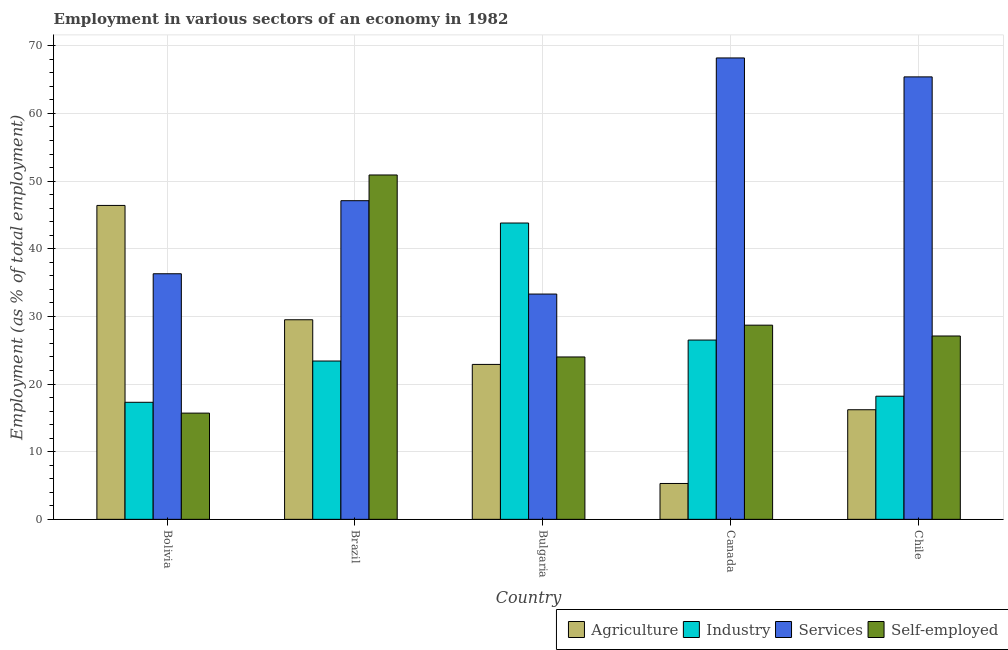How many different coloured bars are there?
Provide a short and direct response. 4. How many groups of bars are there?
Provide a succinct answer. 5. Are the number of bars per tick equal to the number of legend labels?
Provide a succinct answer. Yes. Are the number of bars on each tick of the X-axis equal?
Keep it short and to the point. Yes. How many bars are there on the 1st tick from the left?
Your answer should be compact. 4. How many bars are there on the 2nd tick from the right?
Ensure brevity in your answer.  4. In how many cases, is the number of bars for a given country not equal to the number of legend labels?
Ensure brevity in your answer.  0. What is the percentage of workers in services in Bolivia?
Give a very brief answer. 36.3. Across all countries, what is the maximum percentage of workers in agriculture?
Your answer should be compact. 46.4. Across all countries, what is the minimum percentage of workers in industry?
Give a very brief answer. 17.3. In which country was the percentage of workers in services maximum?
Your answer should be very brief. Canada. What is the total percentage of self employed workers in the graph?
Your answer should be compact. 146.4. What is the difference between the percentage of workers in services in Brazil and that in Chile?
Ensure brevity in your answer.  -18.3. What is the difference between the percentage of workers in agriculture in Canada and the percentage of workers in services in Chile?
Provide a short and direct response. -60.1. What is the average percentage of workers in industry per country?
Ensure brevity in your answer.  25.84. What is the difference between the percentage of self employed workers and percentage of workers in industry in Bolivia?
Ensure brevity in your answer.  -1.6. In how many countries, is the percentage of workers in agriculture greater than 58 %?
Make the answer very short. 0. What is the ratio of the percentage of workers in industry in Bulgaria to that in Canada?
Offer a very short reply. 1.65. Is the percentage of self employed workers in Brazil less than that in Bulgaria?
Your answer should be compact. No. Is the difference between the percentage of workers in agriculture in Canada and Chile greater than the difference between the percentage of self employed workers in Canada and Chile?
Your answer should be very brief. No. What is the difference between the highest and the second highest percentage of workers in services?
Keep it short and to the point. 2.8. What is the difference between the highest and the lowest percentage of workers in agriculture?
Ensure brevity in your answer.  41.1. Is the sum of the percentage of self employed workers in Brazil and Canada greater than the maximum percentage of workers in agriculture across all countries?
Offer a very short reply. Yes. Is it the case that in every country, the sum of the percentage of workers in services and percentage of self employed workers is greater than the sum of percentage of workers in agriculture and percentage of workers in industry?
Keep it short and to the point. No. What does the 4th bar from the left in Chile represents?
Provide a succinct answer. Self-employed. What does the 2nd bar from the right in Canada represents?
Your answer should be very brief. Services. Is it the case that in every country, the sum of the percentage of workers in agriculture and percentage of workers in industry is greater than the percentage of workers in services?
Provide a short and direct response. No. How many bars are there?
Make the answer very short. 20. Are all the bars in the graph horizontal?
Ensure brevity in your answer.  No. What is the difference between two consecutive major ticks on the Y-axis?
Keep it short and to the point. 10. Are the values on the major ticks of Y-axis written in scientific E-notation?
Give a very brief answer. No. Does the graph contain any zero values?
Offer a terse response. No. Does the graph contain grids?
Your answer should be very brief. Yes. Where does the legend appear in the graph?
Ensure brevity in your answer.  Bottom right. How are the legend labels stacked?
Your response must be concise. Horizontal. What is the title of the graph?
Provide a short and direct response. Employment in various sectors of an economy in 1982. What is the label or title of the Y-axis?
Give a very brief answer. Employment (as % of total employment). What is the Employment (as % of total employment) of Agriculture in Bolivia?
Offer a terse response. 46.4. What is the Employment (as % of total employment) in Industry in Bolivia?
Give a very brief answer. 17.3. What is the Employment (as % of total employment) in Services in Bolivia?
Keep it short and to the point. 36.3. What is the Employment (as % of total employment) of Self-employed in Bolivia?
Provide a succinct answer. 15.7. What is the Employment (as % of total employment) in Agriculture in Brazil?
Your answer should be very brief. 29.5. What is the Employment (as % of total employment) in Industry in Brazil?
Ensure brevity in your answer.  23.4. What is the Employment (as % of total employment) of Services in Brazil?
Give a very brief answer. 47.1. What is the Employment (as % of total employment) of Self-employed in Brazil?
Make the answer very short. 50.9. What is the Employment (as % of total employment) of Agriculture in Bulgaria?
Offer a very short reply. 22.9. What is the Employment (as % of total employment) of Industry in Bulgaria?
Give a very brief answer. 43.8. What is the Employment (as % of total employment) in Services in Bulgaria?
Offer a terse response. 33.3. What is the Employment (as % of total employment) of Self-employed in Bulgaria?
Offer a terse response. 24. What is the Employment (as % of total employment) of Agriculture in Canada?
Keep it short and to the point. 5.3. What is the Employment (as % of total employment) of Services in Canada?
Your answer should be compact. 68.2. What is the Employment (as % of total employment) of Self-employed in Canada?
Offer a very short reply. 28.7. What is the Employment (as % of total employment) in Agriculture in Chile?
Offer a very short reply. 16.2. What is the Employment (as % of total employment) of Industry in Chile?
Keep it short and to the point. 18.2. What is the Employment (as % of total employment) in Services in Chile?
Give a very brief answer. 65.4. What is the Employment (as % of total employment) in Self-employed in Chile?
Offer a terse response. 27.1. Across all countries, what is the maximum Employment (as % of total employment) in Agriculture?
Offer a terse response. 46.4. Across all countries, what is the maximum Employment (as % of total employment) of Industry?
Provide a succinct answer. 43.8. Across all countries, what is the maximum Employment (as % of total employment) in Services?
Offer a very short reply. 68.2. Across all countries, what is the maximum Employment (as % of total employment) of Self-employed?
Offer a terse response. 50.9. Across all countries, what is the minimum Employment (as % of total employment) in Agriculture?
Your answer should be compact. 5.3. Across all countries, what is the minimum Employment (as % of total employment) in Industry?
Your response must be concise. 17.3. Across all countries, what is the minimum Employment (as % of total employment) in Services?
Provide a short and direct response. 33.3. Across all countries, what is the minimum Employment (as % of total employment) of Self-employed?
Provide a succinct answer. 15.7. What is the total Employment (as % of total employment) in Agriculture in the graph?
Keep it short and to the point. 120.3. What is the total Employment (as % of total employment) of Industry in the graph?
Provide a short and direct response. 129.2. What is the total Employment (as % of total employment) in Services in the graph?
Make the answer very short. 250.3. What is the total Employment (as % of total employment) in Self-employed in the graph?
Provide a succinct answer. 146.4. What is the difference between the Employment (as % of total employment) in Agriculture in Bolivia and that in Brazil?
Your answer should be compact. 16.9. What is the difference between the Employment (as % of total employment) of Self-employed in Bolivia and that in Brazil?
Make the answer very short. -35.2. What is the difference between the Employment (as % of total employment) of Industry in Bolivia and that in Bulgaria?
Make the answer very short. -26.5. What is the difference between the Employment (as % of total employment) of Agriculture in Bolivia and that in Canada?
Provide a short and direct response. 41.1. What is the difference between the Employment (as % of total employment) in Services in Bolivia and that in Canada?
Provide a short and direct response. -31.9. What is the difference between the Employment (as % of total employment) of Agriculture in Bolivia and that in Chile?
Your answer should be very brief. 30.2. What is the difference between the Employment (as % of total employment) of Services in Bolivia and that in Chile?
Provide a succinct answer. -29.1. What is the difference between the Employment (as % of total employment) in Self-employed in Bolivia and that in Chile?
Your answer should be compact. -11.4. What is the difference between the Employment (as % of total employment) in Industry in Brazil and that in Bulgaria?
Offer a very short reply. -20.4. What is the difference between the Employment (as % of total employment) in Self-employed in Brazil and that in Bulgaria?
Your answer should be very brief. 26.9. What is the difference between the Employment (as % of total employment) in Agriculture in Brazil and that in Canada?
Make the answer very short. 24.2. What is the difference between the Employment (as % of total employment) in Industry in Brazil and that in Canada?
Your response must be concise. -3.1. What is the difference between the Employment (as % of total employment) in Services in Brazil and that in Canada?
Your response must be concise. -21.1. What is the difference between the Employment (as % of total employment) in Agriculture in Brazil and that in Chile?
Make the answer very short. 13.3. What is the difference between the Employment (as % of total employment) of Industry in Brazil and that in Chile?
Give a very brief answer. 5.2. What is the difference between the Employment (as % of total employment) in Services in Brazil and that in Chile?
Keep it short and to the point. -18.3. What is the difference between the Employment (as % of total employment) of Self-employed in Brazil and that in Chile?
Offer a terse response. 23.8. What is the difference between the Employment (as % of total employment) of Services in Bulgaria and that in Canada?
Provide a succinct answer. -34.9. What is the difference between the Employment (as % of total employment) of Agriculture in Bulgaria and that in Chile?
Offer a very short reply. 6.7. What is the difference between the Employment (as % of total employment) of Industry in Bulgaria and that in Chile?
Your answer should be compact. 25.6. What is the difference between the Employment (as % of total employment) in Services in Bulgaria and that in Chile?
Provide a succinct answer. -32.1. What is the difference between the Employment (as % of total employment) of Self-employed in Canada and that in Chile?
Offer a very short reply. 1.6. What is the difference between the Employment (as % of total employment) in Agriculture in Bolivia and the Employment (as % of total employment) in Industry in Brazil?
Give a very brief answer. 23. What is the difference between the Employment (as % of total employment) of Agriculture in Bolivia and the Employment (as % of total employment) of Services in Brazil?
Offer a terse response. -0.7. What is the difference between the Employment (as % of total employment) of Industry in Bolivia and the Employment (as % of total employment) of Services in Brazil?
Offer a very short reply. -29.8. What is the difference between the Employment (as % of total employment) of Industry in Bolivia and the Employment (as % of total employment) of Self-employed in Brazil?
Offer a very short reply. -33.6. What is the difference between the Employment (as % of total employment) of Services in Bolivia and the Employment (as % of total employment) of Self-employed in Brazil?
Provide a succinct answer. -14.6. What is the difference between the Employment (as % of total employment) in Agriculture in Bolivia and the Employment (as % of total employment) in Industry in Bulgaria?
Make the answer very short. 2.6. What is the difference between the Employment (as % of total employment) in Agriculture in Bolivia and the Employment (as % of total employment) in Services in Bulgaria?
Provide a succinct answer. 13.1. What is the difference between the Employment (as % of total employment) in Agriculture in Bolivia and the Employment (as % of total employment) in Self-employed in Bulgaria?
Offer a terse response. 22.4. What is the difference between the Employment (as % of total employment) of Industry in Bolivia and the Employment (as % of total employment) of Services in Bulgaria?
Your answer should be compact. -16. What is the difference between the Employment (as % of total employment) in Industry in Bolivia and the Employment (as % of total employment) in Self-employed in Bulgaria?
Offer a terse response. -6.7. What is the difference between the Employment (as % of total employment) in Services in Bolivia and the Employment (as % of total employment) in Self-employed in Bulgaria?
Give a very brief answer. 12.3. What is the difference between the Employment (as % of total employment) in Agriculture in Bolivia and the Employment (as % of total employment) in Services in Canada?
Give a very brief answer. -21.8. What is the difference between the Employment (as % of total employment) of Agriculture in Bolivia and the Employment (as % of total employment) of Self-employed in Canada?
Offer a very short reply. 17.7. What is the difference between the Employment (as % of total employment) of Industry in Bolivia and the Employment (as % of total employment) of Services in Canada?
Your answer should be very brief. -50.9. What is the difference between the Employment (as % of total employment) of Services in Bolivia and the Employment (as % of total employment) of Self-employed in Canada?
Ensure brevity in your answer.  7.6. What is the difference between the Employment (as % of total employment) in Agriculture in Bolivia and the Employment (as % of total employment) in Industry in Chile?
Make the answer very short. 28.2. What is the difference between the Employment (as % of total employment) in Agriculture in Bolivia and the Employment (as % of total employment) in Self-employed in Chile?
Offer a terse response. 19.3. What is the difference between the Employment (as % of total employment) of Industry in Bolivia and the Employment (as % of total employment) of Services in Chile?
Provide a succinct answer. -48.1. What is the difference between the Employment (as % of total employment) in Industry in Bolivia and the Employment (as % of total employment) in Self-employed in Chile?
Give a very brief answer. -9.8. What is the difference between the Employment (as % of total employment) in Agriculture in Brazil and the Employment (as % of total employment) in Industry in Bulgaria?
Offer a terse response. -14.3. What is the difference between the Employment (as % of total employment) of Agriculture in Brazil and the Employment (as % of total employment) of Self-employed in Bulgaria?
Your answer should be very brief. 5.5. What is the difference between the Employment (as % of total employment) of Industry in Brazil and the Employment (as % of total employment) of Services in Bulgaria?
Offer a very short reply. -9.9. What is the difference between the Employment (as % of total employment) in Services in Brazil and the Employment (as % of total employment) in Self-employed in Bulgaria?
Make the answer very short. 23.1. What is the difference between the Employment (as % of total employment) of Agriculture in Brazil and the Employment (as % of total employment) of Services in Canada?
Provide a succinct answer. -38.7. What is the difference between the Employment (as % of total employment) of Industry in Brazil and the Employment (as % of total employment) of Services in Canada?
Provide a short and direct response. -44.8. What is the difference between the Employment (as % of total employment) in Services in Brazil and the Employment (as % of total employment) in Self-employed in Canada?
Your answer should be very brief. 18.4. What is the difference between the Employment (as % of total employment) of Agriculture in Brazil and the Employment (as % of total employment) of Services in Chile?
Your response must be concise. -35.9. What is the difference between the Employment (as % of total employment) of Agriculture in Brazil and the Employment (as % of total employment) of Self-employed in Chile?
Offer a terse response. 2.4. What is the difference between the Employment (as % of total employment) of Industry in Brazil and the Employment (as % of total employment) of Services in Chile?
Your answer should be compact. -42. What is the difference between the Employment (as % of total employment) of Industry in Brazil and the Employment (as % of total employment) of Self-employed in Chile?
Keep it short and to the point. -3.7. What is the difference between the Employment (as % of total employment) in Services in Brazil and the Employment (as % of total employment) in Self-employed in Chile?
Your answer should be compact. 20. What is the difference between the Employment (as % of total employment) in Agriculture in Bulgaria and the Employment (as % of total employment) in Industry in Canada?
Ensure brevity in your answer.  -3.6. What is the difference between the Employment (as % of total employment) of Agriculture in Bulgaria and the Employment (as % of total employment) of Services in Canada?
Give a very brief answer. -45.3. What is the difference between the Employment (as % of total employment) in Industry in Bulgaria and the Employment (as % of total employment) in Services in Canada?
Provide a short and direct response. -24.4. What is the difference between the Employment (as % of total employment) in Services in Bulgaria and the Employment (as % of total employment) in Self-employed in Canada?
Your answer should be very brief. 4.6. What is the difference between the Employment (as % of total employment) of Agriculture in Bulgaria and the Employment (as % of total employment) of Industry in Chile?
Give a very brief answer. 4.7. What is the difference between the Employment (as % of total employment) in Agriculture in Bulgaria and the Employment (as % of total employment) in Services in Chile?
Give a very brief answer. -42.5. What is the difference between the Employment (as % of total employment) of Industry in Bulgaria and the Employment (as % of total employment) of Services in Chile?
Your answer should be compact. -21.6. What is the difference between the Employment (as % of total employment) of Agriculture in Canada and the Employment (as % of total employment) of Industry in Chile?
Keep it short and to the point. -12.9. What is the difference between the Employment (as % of total employment) of Agriculture in Canada and the Employment (as % of total employment) of Services in Chile?
Provide a succinct answer. -60.1. What is the difference between the Employment (as % of total employment) in Agriculture in Canada and the Employment (as % of total employment) in Self-employed in Chile?
Give a very brief answer. -21.8. What is the difference between the Employment (as % of total employment) in Industry in Canada and the Employment (as % of total employment) in Services in Chile?
Keep it short and to the point. -38.9. What is the difference between the Employment (as % of total employment) of Services in Canada and the Employment (as % of total employment) of Self-employed in Chile?
Offer a terse response. 41.1. What is the average Employment (as % of total employment) of Agriculture per country?
Keep it short and to the point. 24.06. What is the average Employment (as % of total employment) in Industry per country?
Ensure brevity in your answer.  25.84. What is the average Employment (as % of total employment) of Services per country?
Offer a terse response. 50.06. What is the average Employment (as % of total employment) of Self-employed per country?
Your answer should be compact. 29.28. What is the difference between the Employment (as % of total employment) of Agriculture and Employment (as % of total employment) of Industry in Bolivia?
Ensure brevity in your answer.  29.1. What is the difference between the Employment (as % of total employment) in Agriculture and Employment (as % of total employment) in Services in Bolivia?
Give a very brief answer. 10.1. What is the difference between the Employment (as % of total employment) of Agriculture and Employment (as % of total employment) of Self-employed in Bolivia?
Your answer should be compact. 30.7. What is the difference between the Employment (as % of total employment) of Industry and Employment (as % of total employment) of Services in Bolivia?
Offer a terse response. -19. What is the difference between the Employment (as % of total employment) in Services and Employment (as % of total employment) in Self-employed in Bolivia?
Provide a short and direct response. 20.6. What is the difference between the Employment (as % of total employment) of Agriculture and Employment (as % of total employment) of Services in Brazil?
Keep it short and to the point. -17.6. What is the difference between the Employment (as % of total employment) in Agriculture and Employment (as % of total employment) in Self-employed in Brazil?
Give a very brief answer. -21.4. What is the difference between the Employment (as % of total employment) of Industry and Employment (as % of total employment) of Services in Brazil?
Offer a very short reply. -23.7. What is the difference between the Employment (as % of total employment) in Industry and Employment (as % of total employment) in Self-employed in Brazil?
Offer a very short reply. -27.5. What is the difference between the Employment (as % of total employment) of Agriculture and Employment (as % of total employment) of Industry in Bulgaria?
Keep it short and to the point. -20.9. What is the difference between the Employment (as % of total employment) of Industry and Employment (as % of total employment) of Self-employed in Bulgaria?
Your answer should be compact. 19.8. What is the difference between the Employment (as % of total employment) in Services and Employment (as % of total employment) in Self-employed in Bulgaria?
Ensure brevity in your answer.  9.3. What is the difference between the Employment (as % of total employment) in Agriculture and Employment (as % of total employment) in Industry in Canada?
Provide a succinct answer. -21.2. What is the difference between the Employment (as % of total employment) in Agriculture and Employment (as % of total employment) in Services in Canada?
Offer a very short reply. -62.9. What is the difference between the Employment (as % of total employment) in Agriculture and Employment (as % of total employment) in Self-employed in Canada?
Ensure brevity in your answer.  -23.4. What is the difference between the Employment (as % of total employment) in Industry and Employment (as % of total employment) in Services in Canada?
Your response must be concise. -41.7. What is the difference between the Employment (as % of total employment) of Services and Employment (as % of total employment) of Self-employed in Canada?
Your answer should be very brief. 39.5. What is the difference between the Employment (as % of total employment) in Agriculture and Employment (as % of total employment) in Services in Chile?
Provide a short and direct response. -49.2. What is the difference between the Employment (as % of total employment) in Industry and Employment (as % of total employment) in Services in Chile?
Provide a short and direct response. -47.2. What is the difference between the Employment (as % of total employment) of Industry and Employment (as % of total employment) of Self-employed in Chile?
Provide a succinct answer. -8.9. What is the difference between the Employment (as % of total employment) in Services and Employment (as % of total employment) in Self-employed in Chile?
Your answer should be very brief. 38.3. What is the ratio of the Employment (as % of total employment) in Agriculture in Bolivia to that in Brazil?
Provide a short and direct response. 1.57. What is the ratio of the Employment (as % of total employment) in Industry in Bolivia to that in Brazil?
Your answer should be compact. 0.74. What is the ratio of the Employment (as % of total employment) of Services in Bolivia to that in Brazil?
Provide a succinct answer. 0.77. What is the ratio of the Employment (as % of total employment) in Self-employed in Bolivia to that in Brazil?
Your answer should be compact. 0.31. What is the ratio of the Employment (as % of total employment) of Agriculture in Bolivia to that in Bulgaria?
Your response must be concise. 2.03. What is the ratio of the Employment (as % of total employment) of Industry in Bolivia to that in Bulgaria?
Provide a succinct answer. 0.4. What is the ratio of the Employment (as % of total employment) in Services in Bolivia to that in Bulgaria?
Provide a succinct answer. 1.09. What is the ratio of the Employment (as % of total employment) of Self-employed in Bolivia to that in Bulgaria?
Offer a terse response. 0.65. What is the ratio of the Employment (as % of total employment) in Agriculture in Bolivia to that in Canada?
Offer a very short reply. 8.75. What is the ratio of the Employment (as % of total employment) in Industry in Bolivia to that in Canada?
Provide a short and direct response. 0.65. What is the ratio of the Employment (as % of total employment) of Services in Bolivia to that in Canada?
Keep it short and to the point. 0.53. What is the ratio of the Employment (as % of total employment) of Self-employed in Bolivia to that in Canada?
Your answer should be very brief. 0.55. What is the ratio of the Employment (as % of total employment) in Agriculture in Bolivia to that in Chile?
Give a very brief answer. 2.86. What is the ratio of the Employment (as % of total employment) of Industry in Bolivia to that in Chile?
Your response must be concise. 0.95. What is the ratio of the Employment (as % of total employment) in Services in Bolivia to that in Chile?
Offer a terse response. 0.56. What is the ratio of the Employment (as % of total employment) of Self-employed in Bolivia to that in Chile?
Keep it short and to the point. 0.58. What is the ratio of the Employment (as % of total employment) of Agriculture in Brazil to that in Bulgaria?
Give a very brief answer. 1.29. What is the ratio of the Employment (as % of total employment) of Industry in Brazil to that in Bulgaria?
Give a very brief answer. 0.53. What is the ratio of the Employment (as % of total employment) in Services in Brazil to that in Bulgaria?
Your response must be concise. 1.41. What is the ratio of the Employment (as % of total employment) in Self-employed in Brazil to that in Bulgaria?
Provide a succinct answer. 2.12. What is the ratio of the Employment (as % of total employment) in Agriculture in Brazil to that in Canada?
Keep it short and to the point. 5.57. What is the ratio of the Employment (as % of total employment) of Industry in Brazil to that in Canada?
Your response must be concise. 0.88. What is the ratio of the Employment (as % of total employment) in Services in Brazil to that in Canada?
Give a very brief answer. 0.69. What is the ratio of the Employment (as % of total employment) of Self-employed in Brazil to that in Canada?
Keep it short and to the point. 1.77. What is the ratio of the Employment (as % of total employment) in Agriculture in Brazil to that in Chile?
Provide a short and direct response. 1.82. What is the ratio of the Employment (as % of total employment) of Industry in Brazil to that in Chile?
Make the answer very short. 1.29. What is the ratio of the Employment (as % of total employment) in Services in Brazil to that in Chile?
Provide a short and direct response. 0.72. What is the ratio of the Employment (as % of total employment) in Self-employed in Brazil to that in Chile?
Provide a succinct answer. 1.88. What is the ratio of the Employment (as % of total employment) in Agriculture in Bulgaria to that in Canada?
Provide a short and direct response. 4.32. What is the ratio of the Employment (as % of total employment) of Industry in Bulgaria to that in Canada?
Provide a succinct answer. 1.65. What is the ratio of the Employment (as % of total employment) of Services in Bulgaria to that in Canada?
Provide a short and direct response. 0.49. What is the ratio of the Employment (as % of total employment) of Self-employed in Bulgaria to that in Canada?
Ensure brevity in your answer.  0.84. What is the ratio of the Employment (as % of total employment) in Agriculture in Bulgaria to that in Chile?
Provide a short and direct response. 1.41. What is the ratio of the Employment (as % of total employment) in Industry in Bulgaria to that in Chile?
Your answer should be very brief. 2.41. What is the ratio of the Employment (as % of total employment) of Services in Bulgaria to that in Chile?
Ensure brevity in your answer.  0.51. What is the ratio of the Employment (as % of total employment) of Self-employed in Bulgaria to that in Chile?
Provide a short and direct response. 0.89. What is the ratio of the Employment (as % of total employment) in Agriculture in Canada to that in Chile?
Provide a short and direct response. 0.33. What is the ratio of the Employment (as % of total employment) in Industry in Canada to that in Chile?
Offer a very short reply. 1.46. What is the ratio of the Employment (as % of total employment) of Services in Canada to that in Chile?
Ensure brevity in your answer.  1.04. What is the ratio of the Employment (as % of total employment) in Self-employed in Canada to that in Chile?
Provide a succinct answer. 1.06. What is the difference between the highest and the second highest Employment (as % of total employment) of Agriculture?
Your response must be concise. 16.9. What is the difference between the highest and the second highest Employment (as % of total employment) in Self-employed?
Offer a terse response. 22.2. What is the difference between the highest and the lowest Employment (as % of total employment) of Agriculture?
Make the answer very short. 41.1. What is the difference between the highest and the lowest Employment (as % of total employment) of Services?
Make the answer very short. 34.9. What is the difference between the highest and the lowest Employment (as % of total employment) of Self-employed?
Your response must be concise. 35.2. 